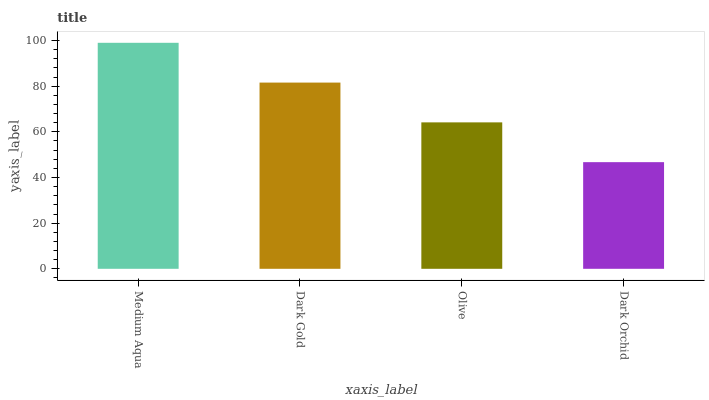Is Dark Orchid the minimum?
Answer yes or no. Yes. Is Medium Aqua the maximum?
Answer yes or no. Yes. Is Dark Gold the minimum?
Answer yes or no. No. Is Dark Gold the maximum?
Answer yes or no. No. Is Medium Aqua greater than Dark Gold?
Answer yes or no. Yes. Is Dark Gold less than Medium Aqua?
Answer yes or no. Yes. Is Dark Gold greater than Medium Aqua?
Answer yes or no. No. Is Medium Aqua less than Dark Gold?
Answer yes or no. No. Is Dark Gold the high median?
Answer yes or no. Yes. Is Olive the low median?
Answer yes or no. Yes. Is Olive the high median?
Answer yes or no. No. Is Medium Aqua the low median?
Answer yes or no. No. 